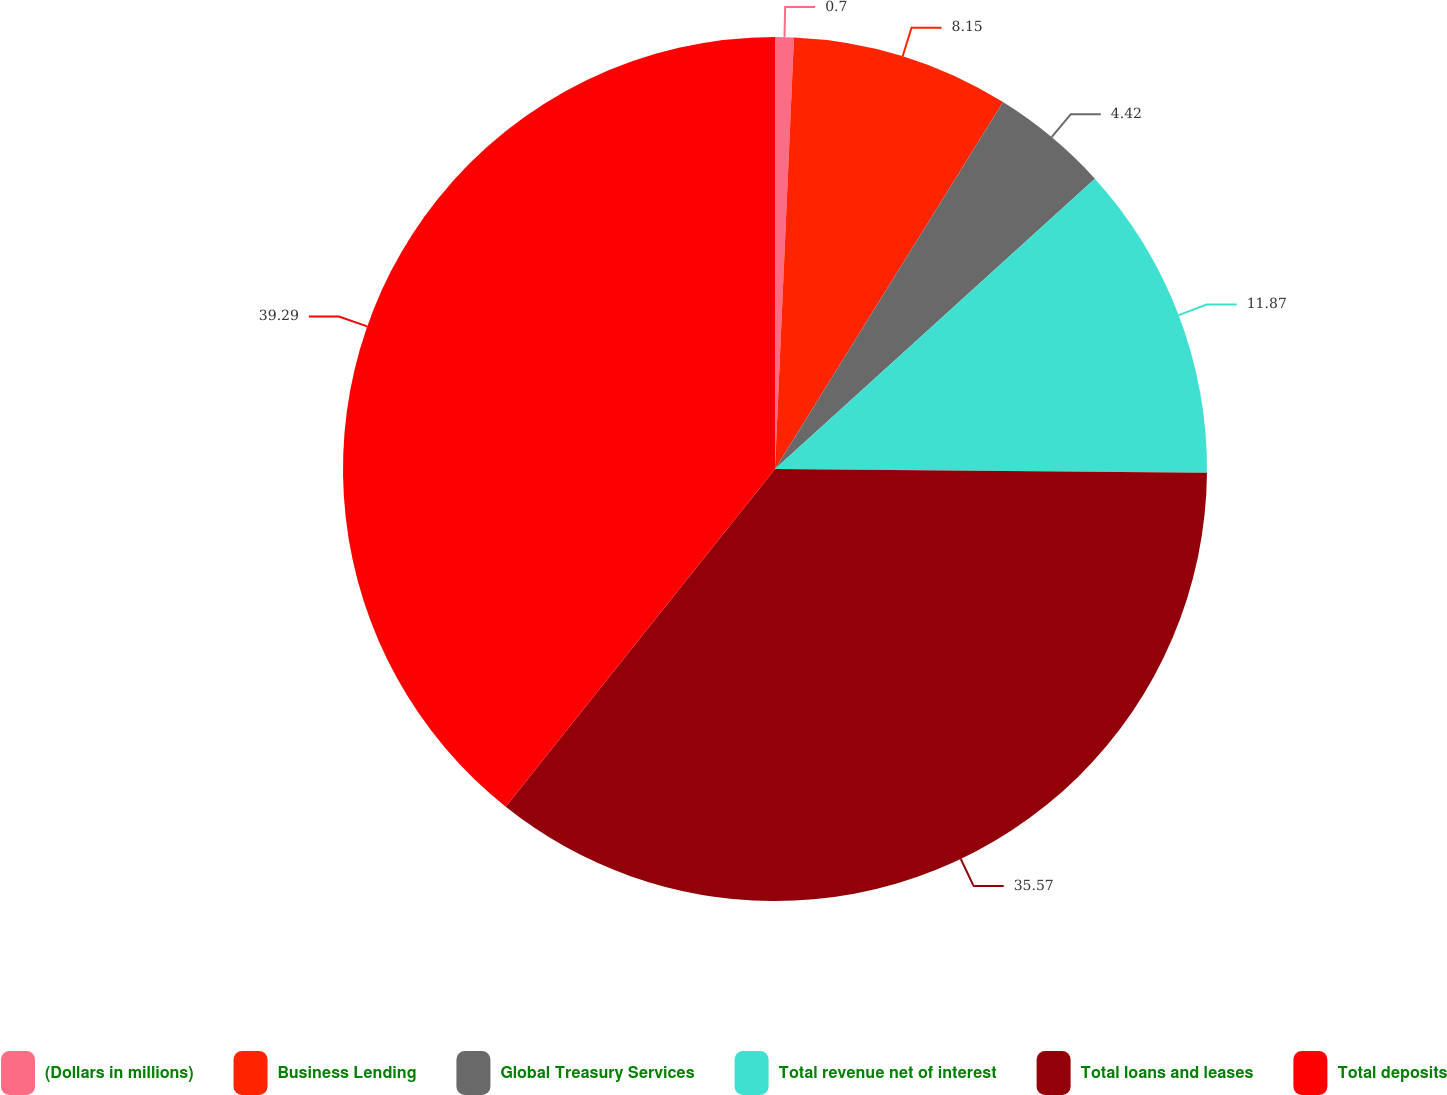Convert chart to OTSL. <chart><loc_0><loc_0><loc_500><loc_500><pie_chart><fcel>(Dollars in millions)<fcel>Business Lending<fcel>Global Treasury Services<fcel>Total revenue net of interest<fcel>Total loans and leases<fcel>Total deposits<nl><fcel>0.7%<fcel>8.15%<fcel>4.42%<fcel>11.87%<fcel>35.57%<fcel>39.29%<nl></chart> 